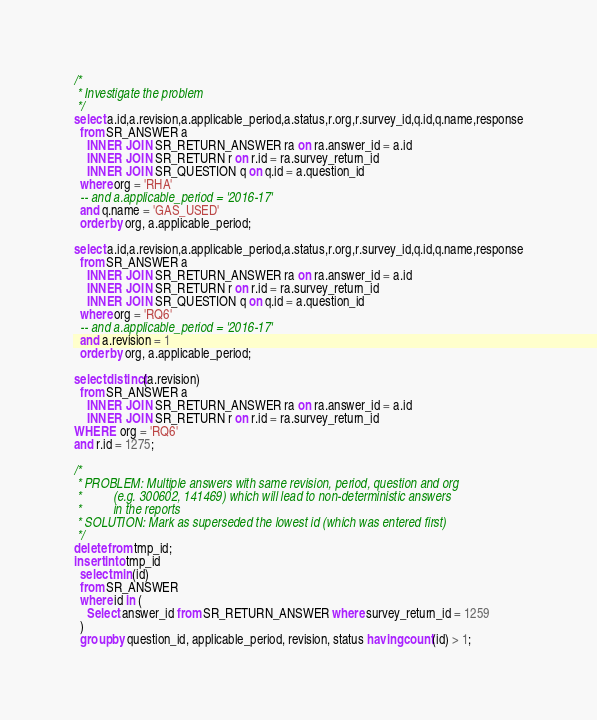<code> <loc_0><loc_0><loc_500><loc_500><_SQL_>/*
 * Investigate the problem
 */
select a.id,a.revision,a.applicable_period,a.status,r.org,r.survey_id,q.id,q.name,response
  from SR_ANSWER a
    INNER JOIN SR_RETURN_ANSWER ra on ra.answer_id = a.id
    INNER JOIN SR_RETURN r on r.id = ra.survey_return_id
    INNER JOIN SR_QUESTION q on q.id = a.question_id
  where org = 'RHA'
  -- and a.applicable_period = '2016-17'
  and q.name = 'GAS_USED'
  order by org, a.applicable_period;

select a.id,a.revision,a.applicable_period,a.status,r.org,r.survey_id,q.id,q.name,response
  from SR_ANSWER a
    INNER JOIN SR_RETURN_ANSWER ra on ra.answer_id = a.id
    INNER JOIN SR_RETURN r on r.id = ra.survey_return_id
    INNER JOIN SR_QUESTION q on q.id = a.question_id
  where org = 'RQ6'
  -- and a.applicable_period = '2016-17'
  and a.revision = 1
  order by org, a.applicable_period;

select distinct(a.revision)
  from SR_ANSWER a
    INNER JOIN SR_RETURN_ANSWER ra on ra.answer_id = a.id
    INNER JOIN SR_RETURN r on r.id = ra.survey_return_id
WHERE org = 'RQ6'
and r.id = 1275;

/*
 * PROBLEM: Multiple answers with same revision, period, question and org
 *          (e.g. 300602, 141469) which will lead to non-deterministic answers
 *          in the reports
 * SOLUTION: Mark as superseded the lowest id (which was entered first)
 */
delete from tmp_id;
insert into tmp_id
  select min(id)
  from SR_ANSWER
  where id in (
    Select answer_id from SR_RETURN_ANSWER where survey_return_id = 1259
  )
  group by question_id, applicable_period, revision, status having count(id) > 1;
</code> 